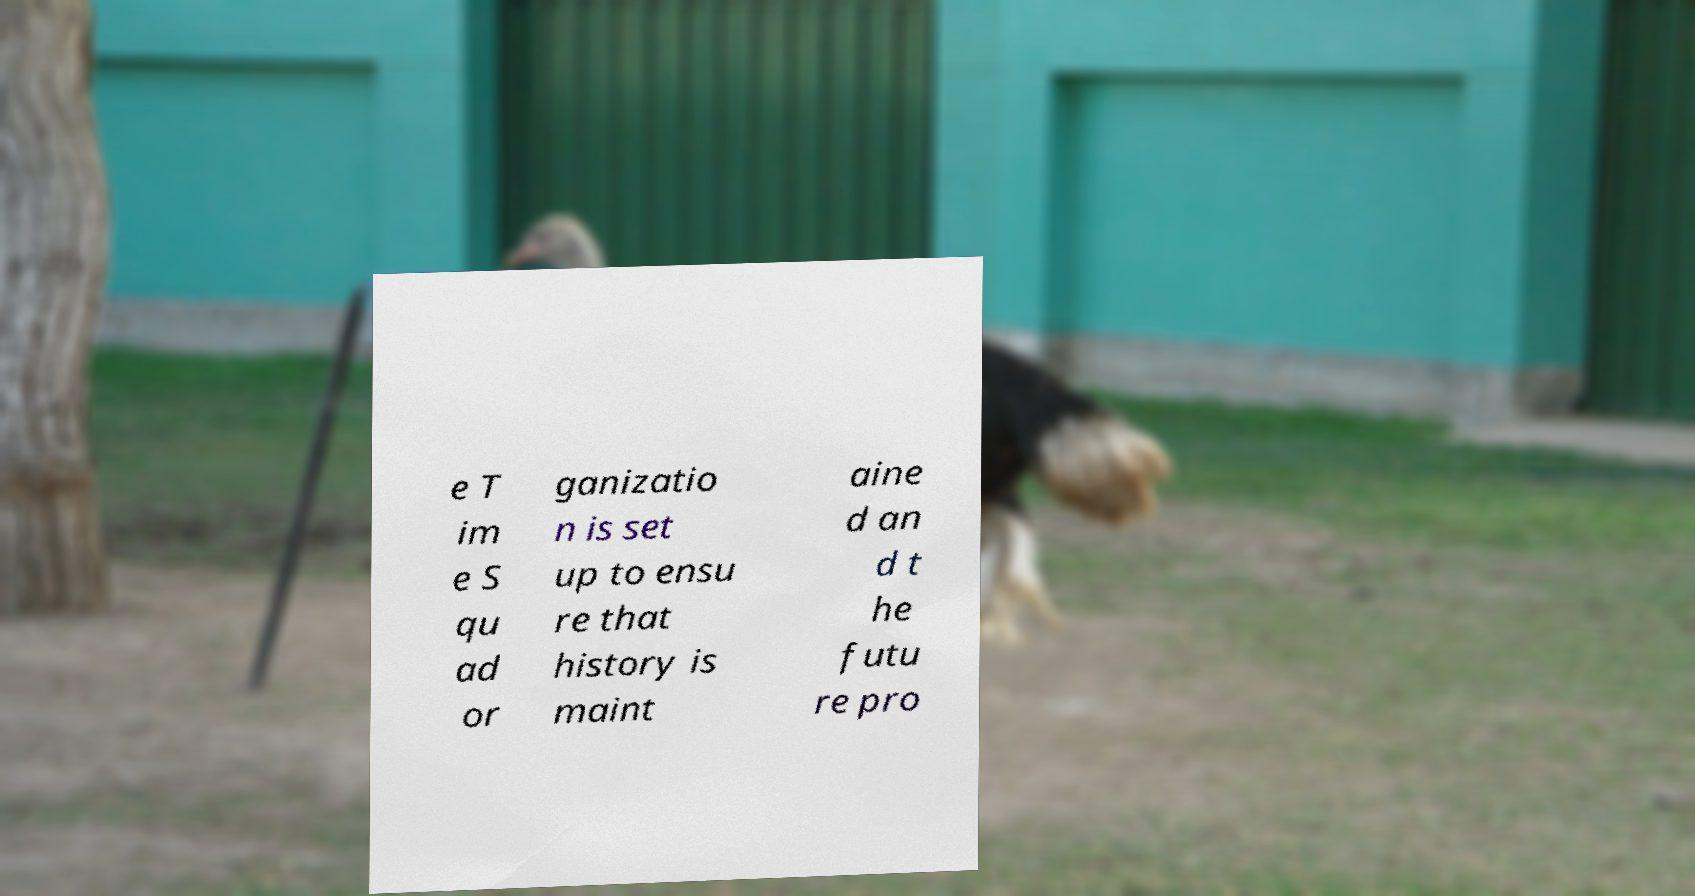Could you extract and type out the text from this image? e T im e S qu ad or ganizatio n is set up to ensu re that history is maint aine d an d t he futu re pro 